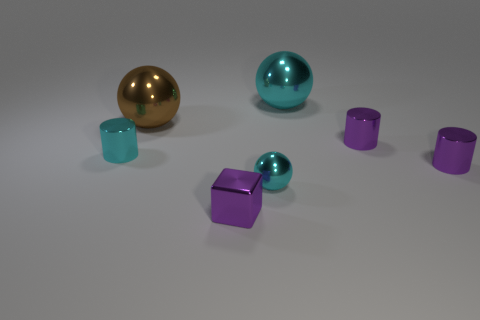Is the number of cyan metallic objects behind the big brown shiny sphere greater than the number of tiny gray cylinders?
Your response must be concise. Yes. What shape is the big thing that is the same color as the small metal sphere?
Give a very brief answer. Sphere. Is there a small object made of the same material as the brown sphere?
Provide a short and direct response. Yes. Do the big ball left of the block and the cyan sphere in front of the large brown object have the same material?
Give a very brief answer. Yes. Are there an equal number of cyan shiny spheres in front of the purple block and cyan metal things on the left side of the cyan metal cylinder?
Your answer should be compact. Yes. What is the color of the sphere that is the same size as the block?
Your answer should be compact. Cyan. Is there a thing of the same color as the block?
Your response must be concise. Yes. How many objects are either small purple shiny things that are right of the purple cube or tiny purple cylinders?
Ensure brevity in your answer.  2. What number of other things are the same size as the cube?
Ensure brevity in your answer.  4. What number of spheres are either big metal things or big cyan shiny objects?
Provide a succinct answer. 2. 